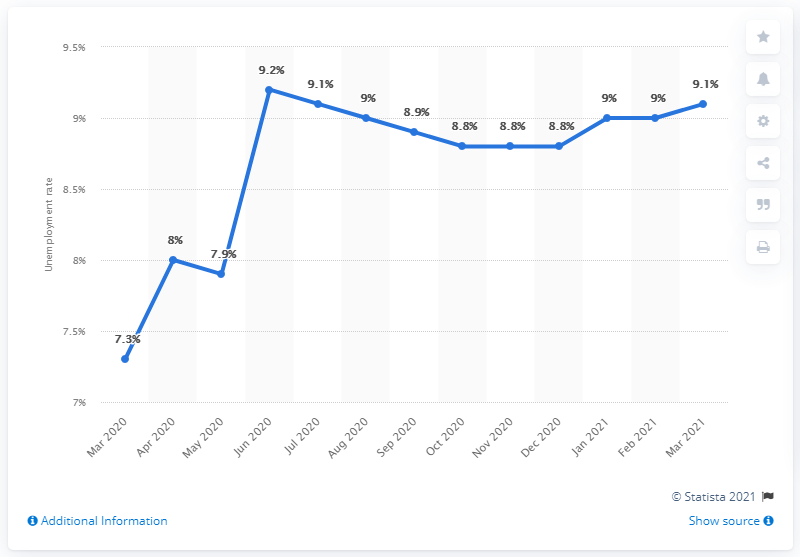Identify some key points in this picture. As of March 2021, the unemployment rate in Sweden was 9.1%. 